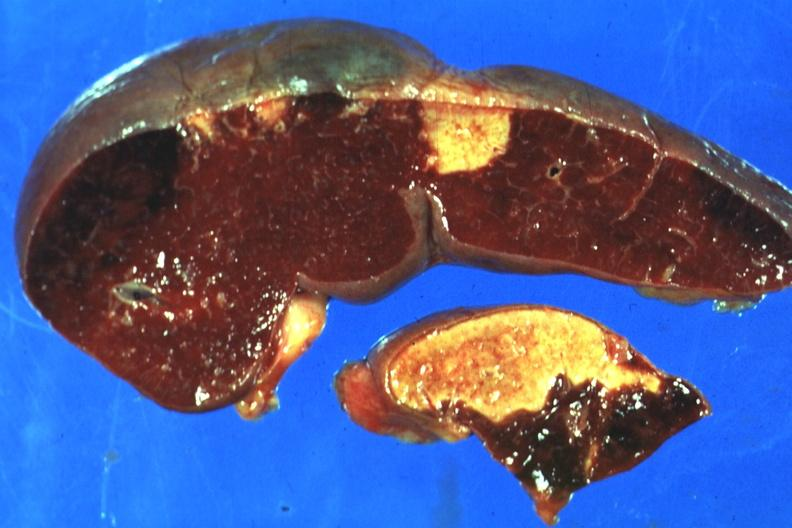how many infarcts does this image show excellent side with shown which are several days of age from nonbacterial endocarditis?
Answer the question using a single word or phrase. Four 